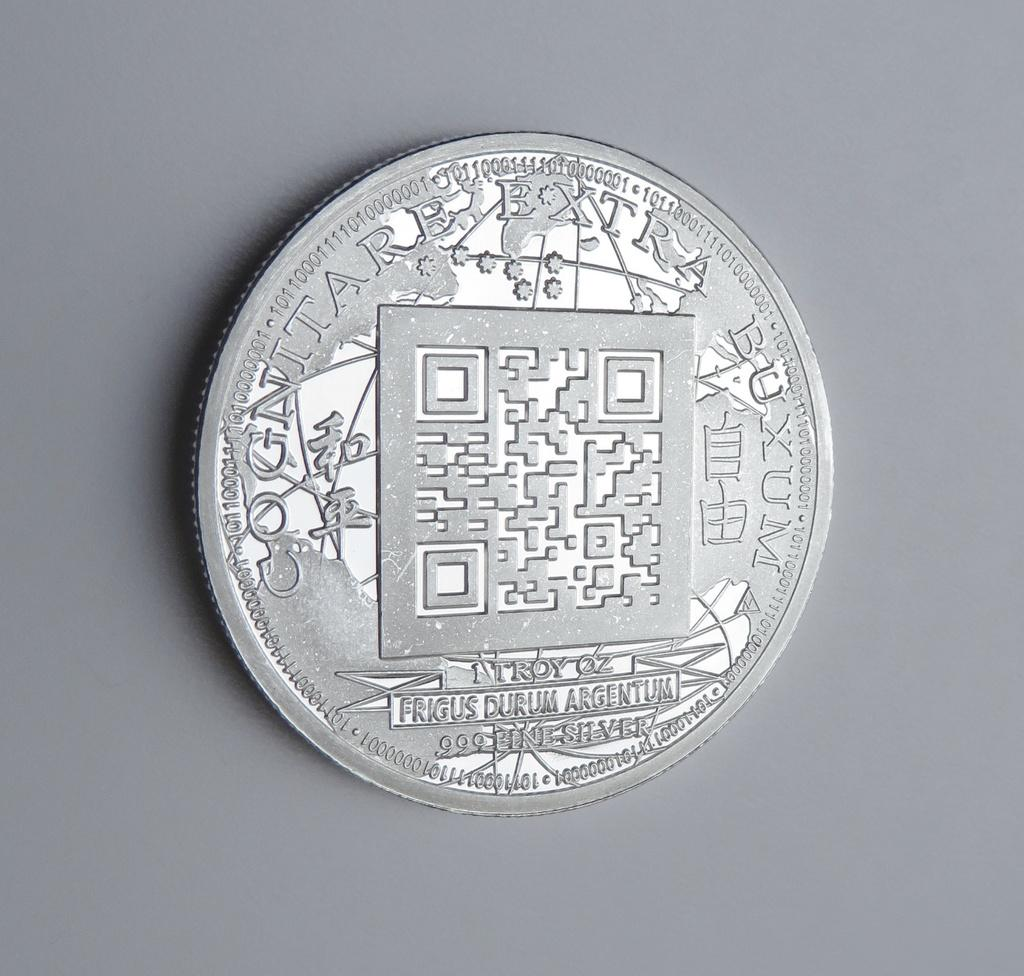<image>
Relay a brief, clear account of the picture shown. A 1 Troy oz coin made of .999 line silver lies on a grey background. 